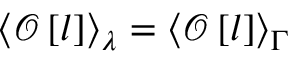<formula> <loc_0><loc_0><loc_500><loc_500>\left < \mathcal { O } \left [ l \right ] \right > _ { \lambda } = \left < \mathcal { O } \left [ l \right ] \right > _ { \Gamma }</formula> 